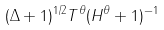Convert formula to latex. <formula><loc_0><loc_0><loc_500><loc_500>( \Delta + 1 ) ^ { 1 / 2 } T ^ { \theta } ( H ^ { \theta } + 1 ) ^ { - 1 }</formula> 